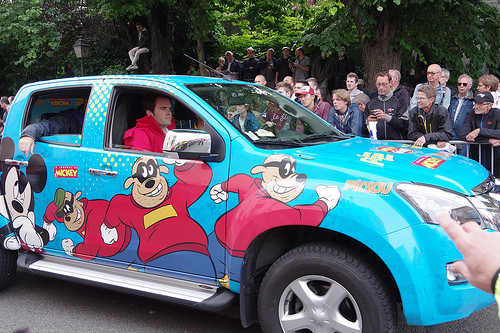<image>
Is the cartoon in the car? No. The cartoon is not contained within the car. These objects have a different spatial relationship. Where is the cartoon in relation to the truck? Is it on the truck? Yes. Looking at the image, I can see the cartoon is positioned on top of the truck, with the truck providing support. 